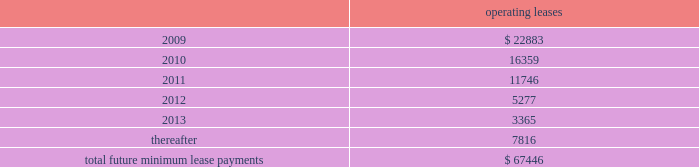Notes to consolidated financial statements 2014 ( continued ) note 12 2014related party transactions in the course of settling money transfer transactions , we purchase foreign currency from consultoria internacional casa de cambio ( 201ccisa 201d ) , a mexican company partially owned by certain of our employees .
As of march 31 , 2008 , mr .
Ra fal lim f3n cortes , a 10% ( 10 % ) shareholder of cisa , was no longer an employee , and we no longer considered cisa a related party .
We purchased 6.1 billion mexican pesos for $ 560.3 million during the ten months ended march 31 , 2008 and 8.1 billion mexican pesos for $ 736.0 million during fiscal 2007 from cisa .
We believe these currency transactions were executed at prevailing market exchange rates .
Also from time to time , money transfer transactions are settled at destination facilities owned by cisa .
We incurred related settlement expenses , included in cost of service in the accompanying consolidated statements of income of $ 0.5 million in the ten months ended march 31 , 2008 .
In fiscal 2007 and 2006 , we incurred related settlement expenses , included in cost of service in the accompanying consolidated statements of income of $ 0.7 and $ 0.6 million , respectively .
In the normal course of business , we periodically utilize the services of contractors to provide software development services .
One of our employees , hired in april 2005 , is also an employee , officer , and part owner of a firm that provides such services .
The services provided by this firm primarily relate to software development in connection with our planned next generation front-end processing system in the united states .
During fiscal 2008 , we capitalized fees paid to this firm of $ 0.3 million .
As of may 31 , 2008 and 2007 , capitalized amounts paid to this firm of $ 4.9 million and $ 4.6 million , respectively , were included in property and equipment in the accompanying consolidated balance sheets .
In addition , we expensed amounts paid to this firm of $ 0.3 million , $ 0.1 million and $ 0.5 million in the years ended may 31 , 2008 , 2007 and 2006 , respectively .
Note 13 2014commitments and contingencies leases we conduct a major part of our operations using leased facilities and equipment .
Many of these leases have renewal and purchase options and provide that we pay the cost of property taxes , insurance and maintenance .
Rent expense on all operating leases for fiscal 2008 , 2007 and 2006 was $ 30.4 million , $ 27.1 million , and $ 24.4 million , respectively .
Future minimum lease payments for all noncancelable leases at may 31 , 2008 were as follows : operating leases .
We are party to a number of other claims and lawsuits incidental to our business .
In the opinion of management , the reasonably possible outcome of such matters , individually or in the aggregate , will not have a material adverse impact on our financial position , liquidity or results of operations. .
What is the exchange rate pesos to dollar in 2007? 
Computations: ((8.1 - 1000) / 736.0)
Answer: -1.34769. 